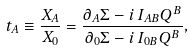Convert formula to latex. <formula><loc_0><loc_0><loc_500><loc_500>t _ { A } \equiv \frac { X _ { A } } { X _ { 0 } } = \frac { \partial _ { A } \Sigma - i \, I _ { A B } Q ^ { B } } { \partial _ { 0 } \Sigma - i \, I _ { 0 B } Q ^ { B } } ,</formula> 